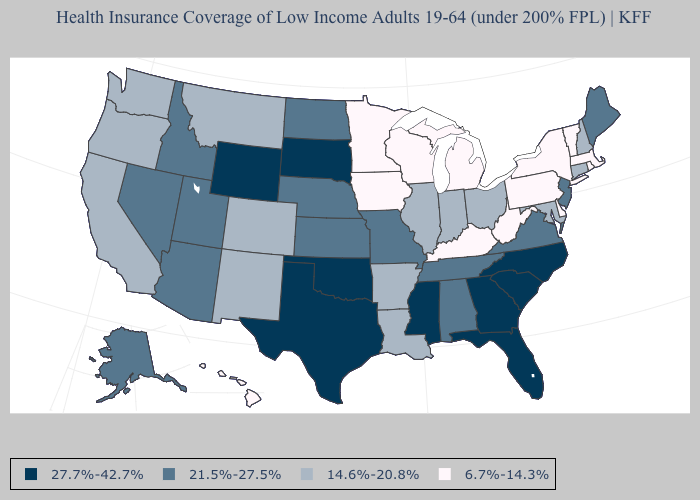Name the states that have a value in the range 6.7%-14.3%?
Keep it brief. Delaware, Hawaii, Iowa, Kentucky, Massachusetts, Michigan, Minnesota, New York, Pennsylvania, Rhode Island, Vermont, West Virginia, Wisconsin. What is the highest value in the USA?
Give a very brief answer. 27.7%-42.7%. Among the states that border Ohio , which have the highest value?
Write a very short answer. Indiana. Name the states that have a value in the range 21.5%-27.5%?
Quick response, please. Alabama, Alaska, Arizona, Idaho, Kansas, Maine, Missouri, Nebraska, Nevada, New Jersey, North Dakota, Tennessee, Utah, Virginia. Does the map have missing data?
Keep it brief. No. What is the value of New Hampshire?
Short answer required. 14.6%-20.8%. Among the states that border Tennessee , which have the highest value?
Keep it brief. Georgia, Mississippi, North Carolina. Name the states that have a value in the range 6.7%-14.3%?
Answer briefly. Delaware, Hawaii, Iowa, Kentucky, Massachusetts, Michigan, Minnesota, New York, Pennsylvania, Rhode Island, Vermont, West Virginia, Wisconsin. Name the states that have a value in the range 6.7%-14.3%?
Write a very short answer. Delaware, Hawaii, Iowa, Kentucky, Massachusetts, Michigan, Minnesota, New York, Pennsylvania, Rhode Island, Vermont, West Virginia, Wisconsin. Name the states that have a value in the range 21.5%-27.5%?
Answer briefly. Alabama, Alaska, Arizona, Idaho, Kansas, Maine, Missouri, Nebraska, Nevada, New Jersey, North Dakota, Tennessee, Utah, Virginia. Name the states that have a value in the range 21.5%-27.5%?
Short answer required. Alabama, Alaska, Arizona, Idaho, Kansas, Maine, Missouri, Nebraska, Nevada, New Jersey, North Dakota, Tennessee, Utah, Virginia. Name the states that have a value in the range 14.6%-20.8%?
Be succinct. Arkansas, California, Colorado, Connecticut, Illinois, Indiana, Louisiana, Maryland, Montana, New Hampshire, New Mexico, Ohio, Oregon, Washington. Name the states that have a value in the range 21.5%-27.5%?
Short answer required. Alabama, Alaska, Arizona, Idaho, Kansas, Maine, Missouri, Nebraska, Nevada, New Jersey, North Dakota, Tennessee, Utah, Virginia. Does Hawaii have the lowest value in the West?
Be succinct. Yes. 